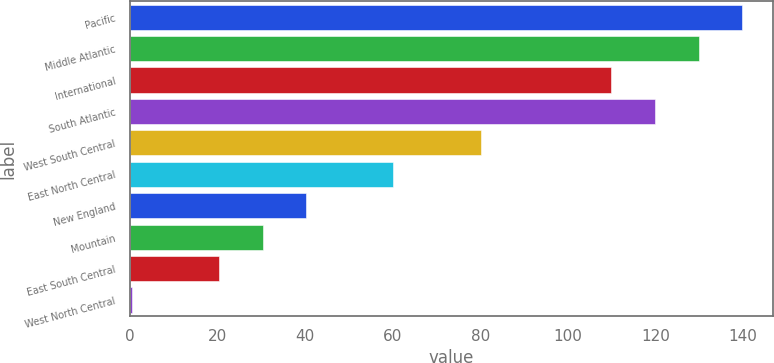Convert chart. <chart><loc_0><loc_0><loc_500><loc_500><bar_chart><fcel>Pacific<fcel>Middle Atlantic<fcel>International<fcel>South Atlantic<fcel>West South Central<fcel>East North Central<fcel>New England<fcel>Mountain<fcel>East South Central<fcel>West North Central<nl><fcel>139.84<fcel>129.88<fcel>109.96<fcel>119.92<fcel>80.08<fcel>60.16<fcel>40.24<fcel>30.28<fcel>20.32<fcel>0.4<nl></chart> 